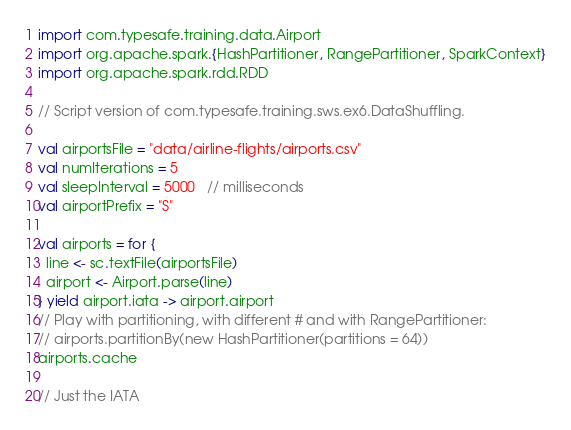<code> <loc_0><loc_0><loc_500><loc_500><_Scala_>import com.typesafe.training.data.Airport
import org.apache.spark.{HashPartitioner, RangePartitioner, SparkContext}
import org.apache.spark.rdd.RDD

// Script version of com.typesafe.training.sws.ex6.DataShuffling.

val airportsFile = "data/airline-flights/airports.csv"
val numIterations = 5
val sleepInterval = 5000   // milliseconds
val airportPrefix = "S"

val airports = for {
  line <- sc.textFile(airportsFile)
  airport <- Airport.parse(line)
} yield airport.iata -> airport.airport
// Play with partitioning, with different # and with RangePartitioner:
// airports.partitionBy(new HashPartitioner(partitions = 64))
airports.cache

// Just the IATA</code> 